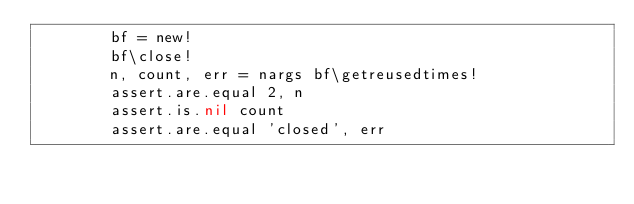Convert code to text. <code><loc_0><loc_0><loc_500><loc_500><_MoonScript_>        bf = new!
        bf\close!
        n, count, err = nargs bf\getreusedtimes!
        assert.are.equal 2, n
        assert.is.nil count
        assert.are.equal 'closed', err
</code> 